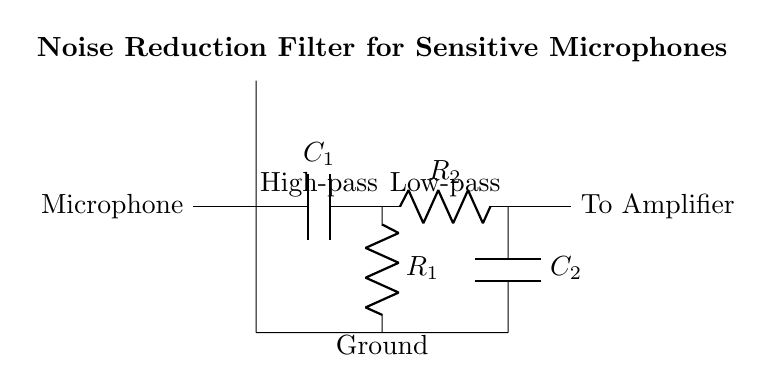What components make up the filter? The components include a capacitor C1, a resistor R1, another resistor R2, and another capacitor C2.
Answer: C1, R1, R2, C2 What does C1 represent in the circuit? C1 is a capacitor that performs a high-pass filtering function, blocking low-frequency noise while allowing higher frequencies to pass.
Answer: High-pass filter How many resistors are in the circuit? There are two resistors present, R1 and R2.
Answer: 2 What is the path from the microphone to the amplifier? The path goes from the microphone to C1, then through R1, into R2, and finally to the amplifier.
Answer: Microphone to C1 to R1 to R2 to Amplifier Which filtering function does R2 and C2 serve? R2 and C2 form a low-pass filter that allows low-frequency signals to pass through while attenuating high-frequency noise.
Answer: Low-pass filter What does the ground connection signify? The ground connection indicates a common reference point for the circuit, helping to stabilize voltage levels throughout the components.
Answer: Reference point What is the purpose of this circuit diagram? The circuit diagram shows a noise reduction filter designed to clean up audio signals from sensitive microphones in film production.
Answer: Noise reduction filter 